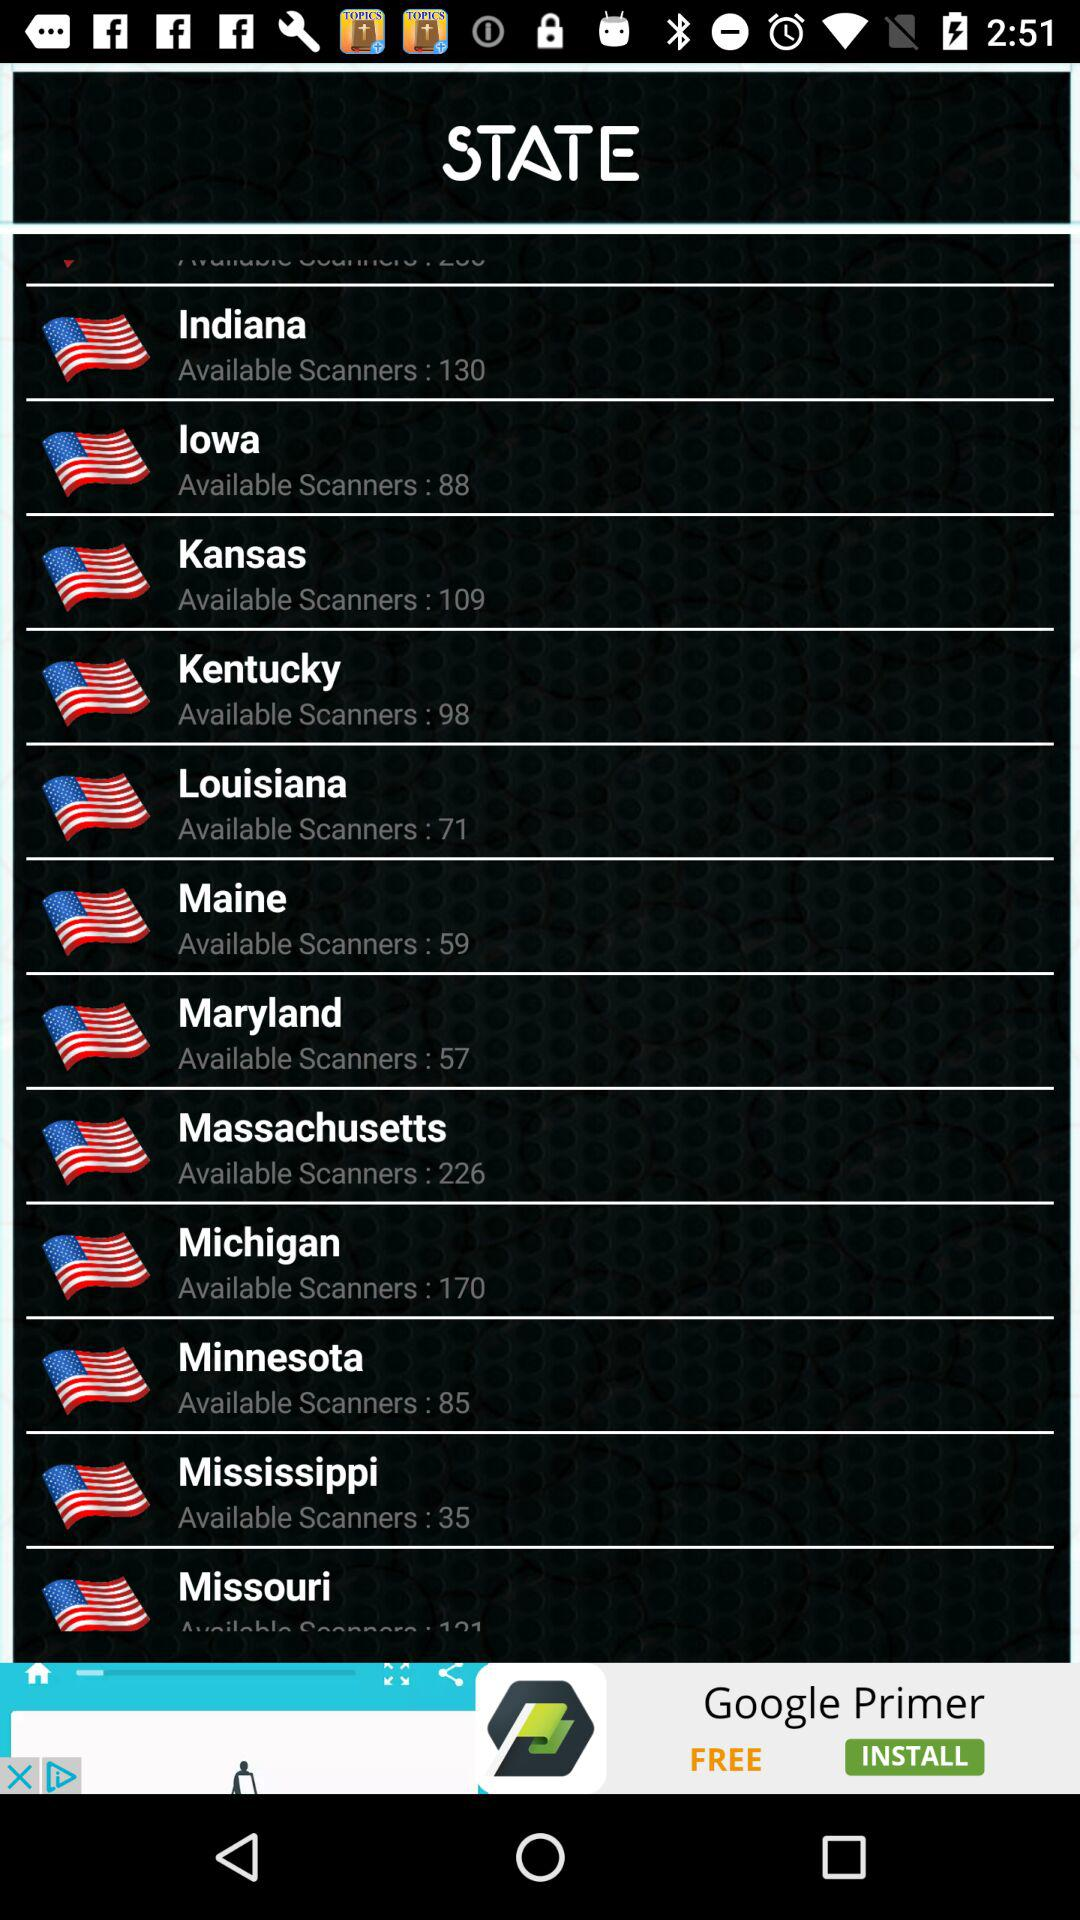Which state has 35 scanners? The state is Mississippi. 